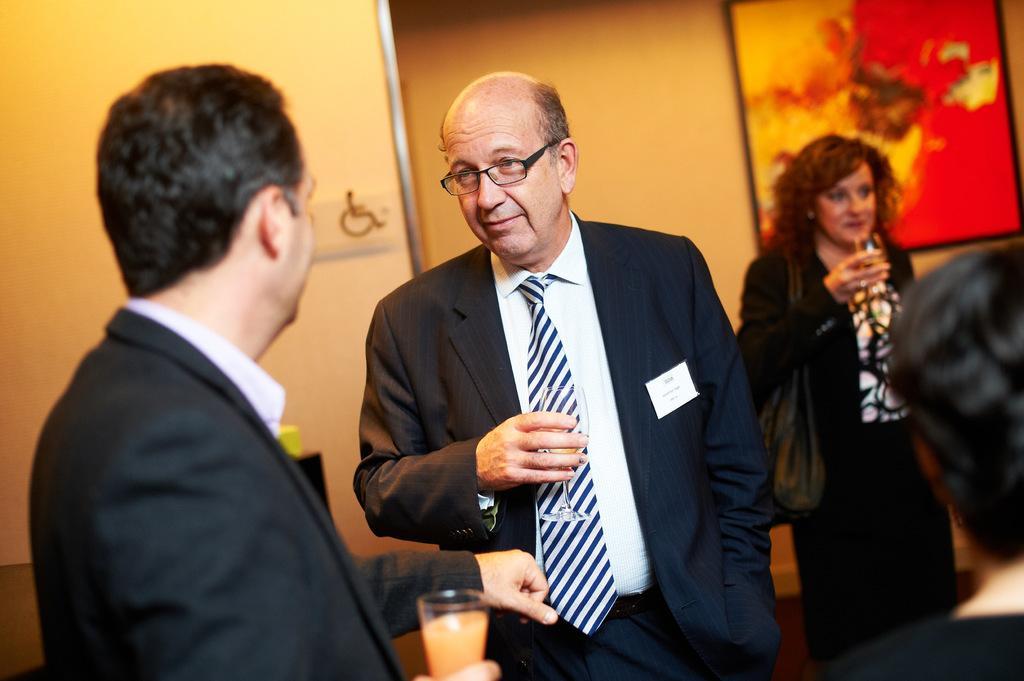In one or two sentences, can you explain what this image depicts? In the picture we can see two men are standing facing to each other, they are holding glasses with drink and they are in blazers, ties and shirts and behind them, we can see a woman standing with glass and he's also in blazer and handbag and near to her we can see a person standing and in the background we can see a wall with a painting on it. 